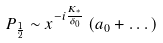<formula> <loc_0><loc_0><loc_500><loc_500>P _ { \frac { 1 } { 2 } } \sim x ^ { - i \frac { K _ { ^ { * } } } { \delta _ { 0 } } } \left ( a _ { 0 } + \dots \right )</formula> 